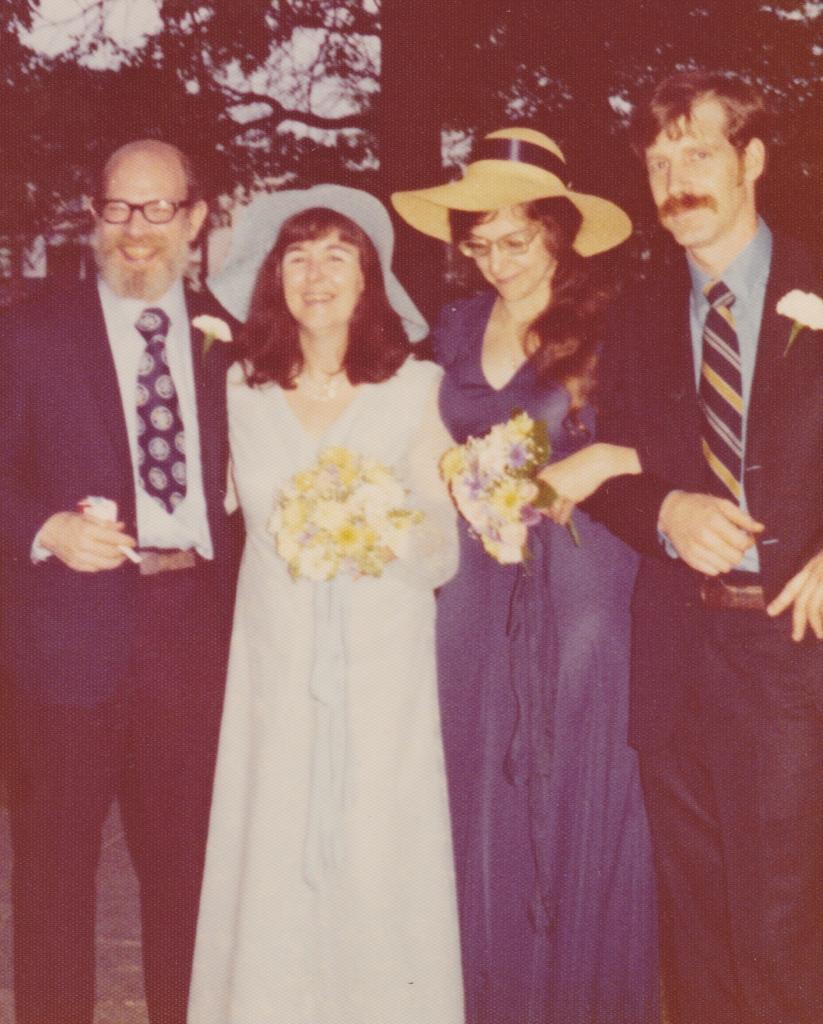Could you give a brief overview of what you see in this image? In this image we can see a group of persons are standing, and smiling, and holding a flower bokeh in the hands, at the back there are trees. 